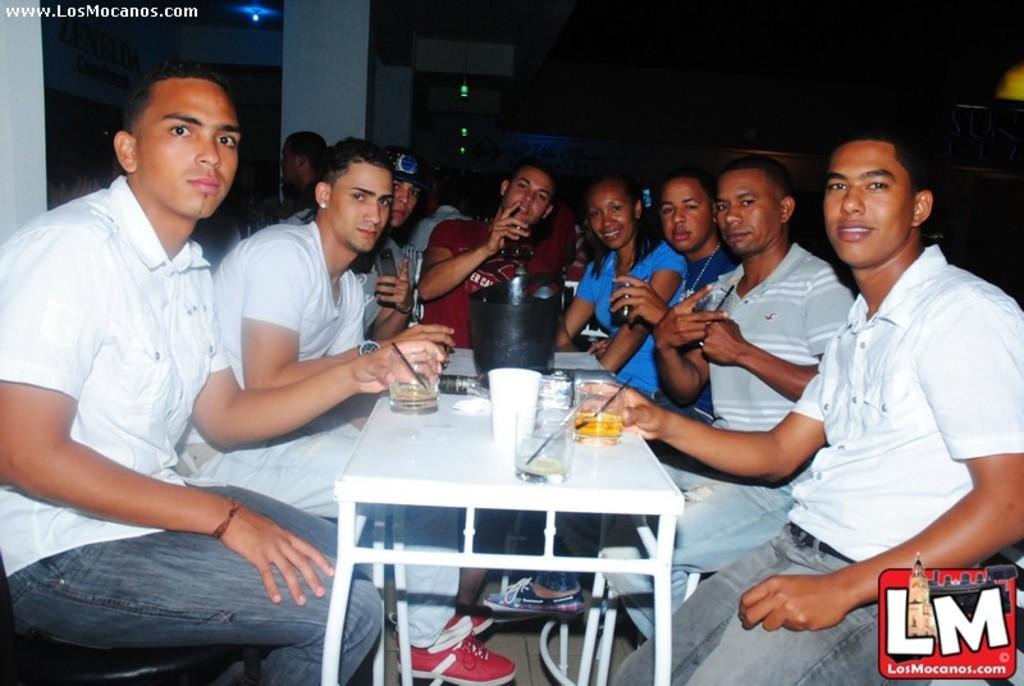How would you summarize this image in a sentence or two? In this image we can see a group of people sitting beside a table containing some glasses, a bottle and a container. In that two men are holding glasses and the other is holding a cigarette. On the backside we can see a wall and some lights. On the bottom of the image we can see a logo. 